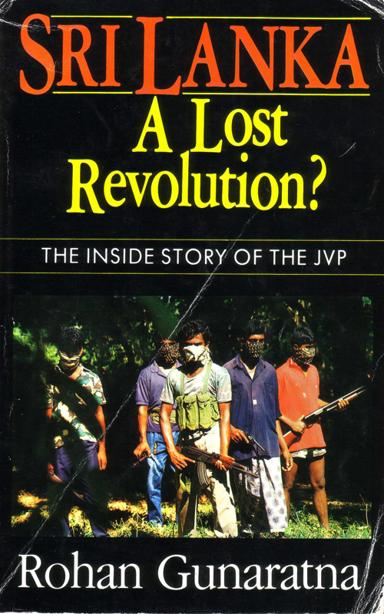Can you describe the scene depicted on the book cover? The book cover shows a group of five individuals, likely militants, in a jungle setting. They appear to be in combat attire with camouflage and armed with weapons. This imagery suggests a militant or revolutionary context, aligning with the subject matter of the book which explores the Janatha Vimukthi Peramuna (JVP) insurgency in Sri Lanka. 